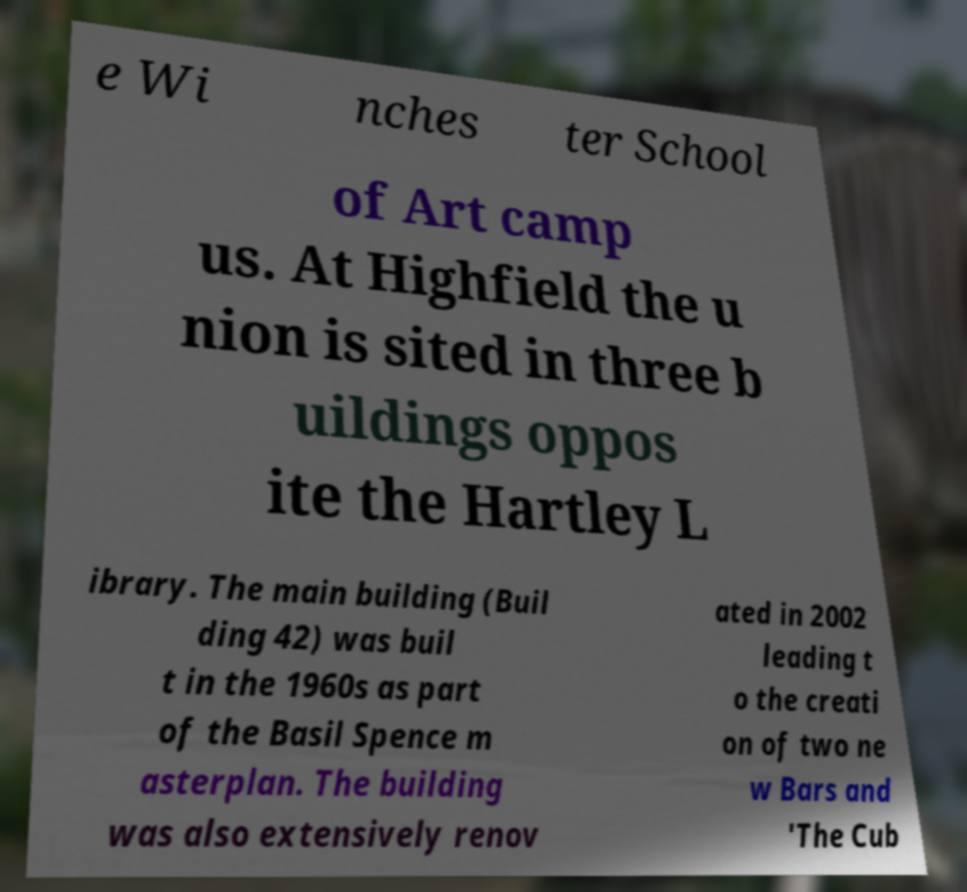What messages or text are displayed in this image? I need them in a readable, typed format. e Wi nches ter School of Art camp us. At Highfield the u nion is sited in three b uildings oppos ite the Hartley L ibrary. The main building (Buil ding 42) was buil t in the 1960s as part of the Basil Spence m asterplan. The building was also extensively renov ated in 2002 leading t o the creati on of two ne w Bars and 'The Cub 